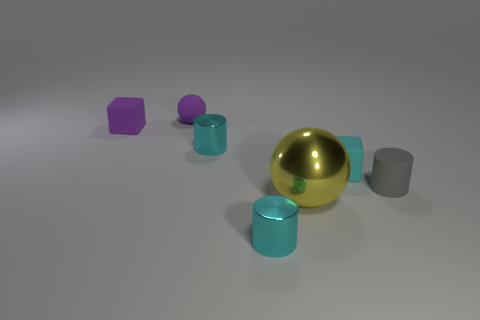Describe the textures visible in this image. The objects exhibit a range of textures. The spherical and cylindrical objects reflect light smoothly, indicating a metallic or polished surface. The cubes show a more matte finish, which absorbs light and provides a contrast to the other objects. 